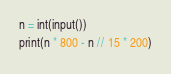<code> <loc_0><loc_0><loc_500><loc_500><_Python_>n = int(input())
print(n * 800 - n // 15 * 200)</code> 